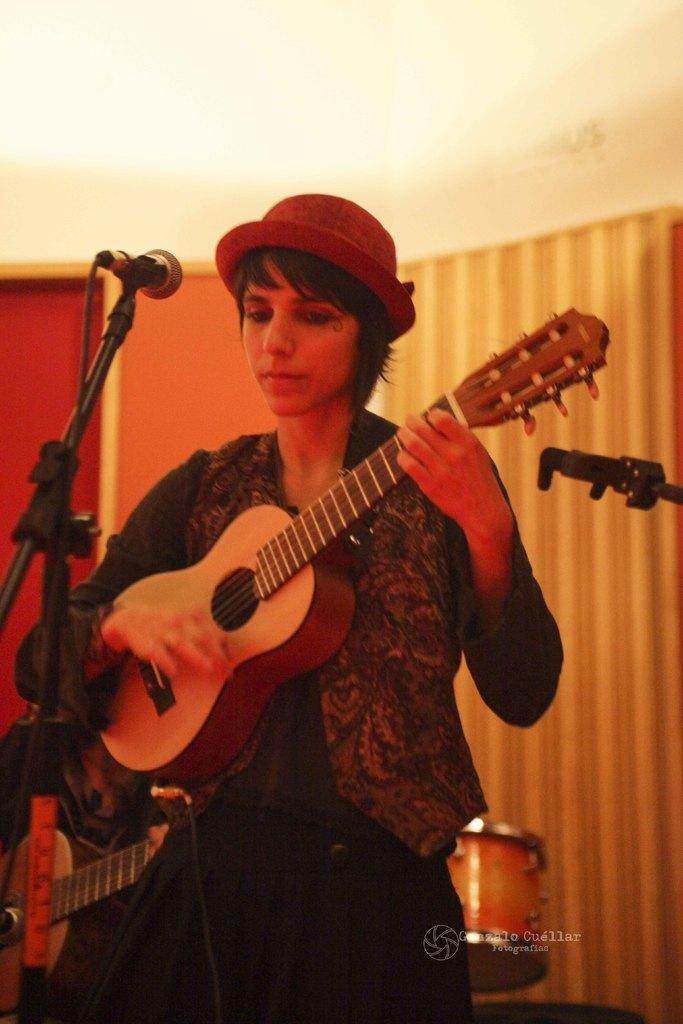What is the lady in the image holding? The lady is holding a guitar in her hand. What is placed in front of the lady? There is a microphone placed before her. What can be seen in the background of the image? There is a drum, a wall, and a curtain in the background of the image. What color is the turkey that is sitting on the curtain in the image? There is no turkey present in the image; it only features a lady holding a guitar, a microphone, a drum, a wall, and a curtain in the background. 